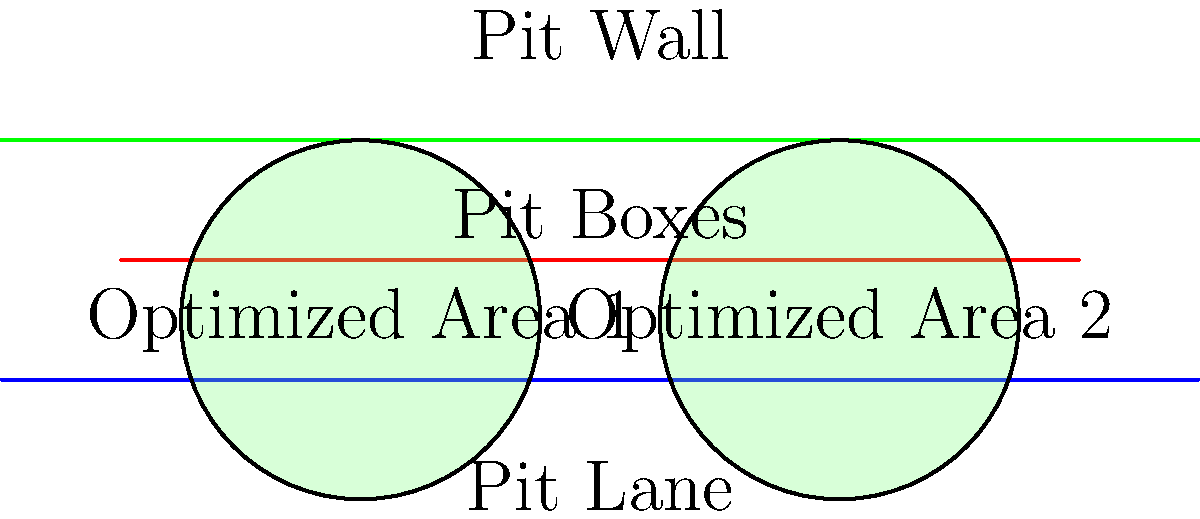In the topological optimization of a pit stop layout, two key areas have been identified for efficiency improvement. Given that the average pit stop time is currently 3.2 seconds, what percentage reduction in pit stop time could be achieved if the optimized areas reduce equipment retrieval time by 0.3 seconds each? To solve this problem, we'll follow these steps:

1. Identify the current pit stop time:
   Current pit stop time = 3.2 seconds

2. Calculate the total time saved from both optimized areas:
   Time saved per area = 0.3 seconds
   Total time saved = 0.3 seconds × 2 areas = 0.6 seconds

3. Calculate the new pit stop time after optimization:
   New pit stop time = Current time - Time saved
   New pit stop time = 3.2 seconds - 0.6 seconds = 2.6 seconds

4. Calculate the percentage reduction:
   Percentage reduction = (Time saved / Original time) × 100%
   Percentage reduction = (0.6 seconds / 3.2 seconds) × 100%
   Percentage reduction = 0.1875 × 100% = 18.75%

Therefore, the topological optimization could achieve a 18.75% reduction in pit stop time.
Answer: 18.75% 